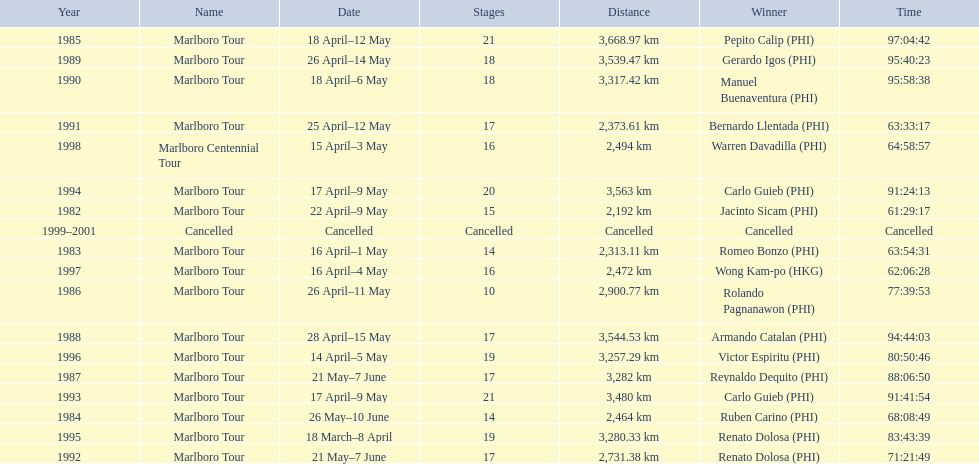Which year did warren davdilla (w.d.) appear? 1998. What tour did w.d. complete? Marlboro Centennial Tour. What is the time recorded in the same row as w.d.? 64:58:57. 